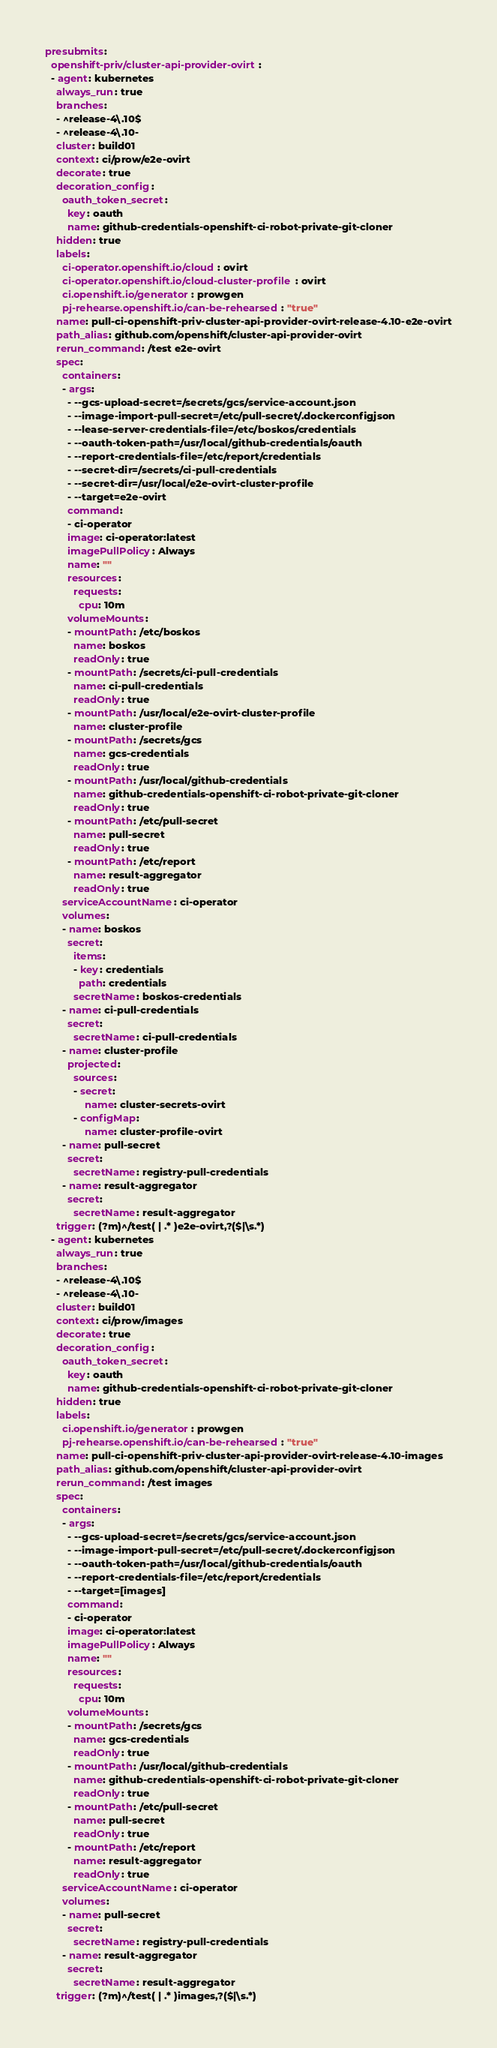<code> <loc_0><loc_0><loc_500><loc_500><_YAML_>presubmits:
  openshift-priv/cluster-api-provider-ovirt:
  - agent: kubernetes
    always_run: true
    branches:
    - ^release-4\.10$
    - ^release-4\.10-
    cluster: build01
    context: ci/prow/e2e-ovirt
    decorate: true
    decoration_config:
      oauth_token_secret:
        key: oauth
        name: github-credentials-openshift-ci-robot-private-git-cloner
    hidden: true
    labels:
      ci-operator.openshift.io/cloud: ovirt
      ci-operator.openshift.io/cloud-cluster-profile: ovirt
      ci.openshift.io/generator: prowgen
      pj-rehearse.openshift.io/can-be-rehearsed: "true"
    name: pull-ci-openshift-priv-cluster-api-provider-ovirt-release-4.10-e2e-ovirt
    path_alias: github.com/openshift/cluster-api-provider-ovirt
    rerun_command: /test e2e-ovirt
    spec:
      containers:
      - args:
        - --gcs-upload-secret=/secrets/gcs/service-account.json
        - --image-import-pull-secret=/etc/pull-secret/.dockerconfigjson
        - --lease-server-credentials-file=/etc/boskos/credentials
        - --oauth-token-path=/usr/local/github-credentials/oauth
        - --report-credentials-file=/etc/report/credentials
        - --secret-dir=/secrets/ci-pull-credentials
        - --secret-dir=/usr/local/e2e-ovirt-cluster-profile
        - --target=e2e-ovirt
        command:
        - ci-operator
        image: ci-operator:latest
        imagePullPolicy: Always
        name: ""
        resources:
          requests:
            cpu: 10m
        volumeMounts:
        - mountPath: /etc/boskos
          name: boskos
          readOnly: true
        - mountPath: /secrets/ci-pull-credentials
          name: ci-pull-credentials
          readOnly: true
        - mountPath: /usr/local/e2e-ovirt-cluster-profile
          name: cluster-profile
        - mountPath: /secrets/gcs
          name: gcs-credentials
          readOnly: true
        - mountPath: /usr/local/github-credentials
          name: github-credentials-openshift-ci-robot-private-git-cloner
          readOnly: true
        - mountPath: /etc/pull-secret
          name: pull-secret
          readOnly: true
        - mountPath: /etc/report
          name: result-aggregator
          readOnly: true
      serviceAccountName: ci-operator
      volumes:
      - name: boskos
        secret:
          items:
          - key: credentials
            path: credentials
          secretName: boskos-credentials
      - name: ci-pull-credentials
        secret:
          secretName: ci-pull-credentials
      - name: cluster-profile
        projected:
          sources:
          - secret:
              name: cluster-secrets-ovirt
          - configMap:
              name: cluster-profile-ovirt
      - name: pull-secret
        secret:
          secretName: registry-pull-credentials
      - name: result-aggregator
        secret:
          secretName: result-aggregator
    trigger: (?m)^/test( | .* )e2e-ovirt,?($|\s.*)
  - agent: kubernetes
    always_run: true
    branches:
    - ^release-4\.10$
    - ^release-4\.10-
    cluster: build01
    context: ci/prow/images
    decorate: true
    decoration_config:
      oauth_token_secret:
        key: oauth
        name: github-credentials-openshift-ci-robot-private-git-cloner
    hidden: true
    labels:
      ci.openshift.io/generator: prowgen
      pj-rehearse.openshift.io/can-be-rehearsed: "true"
    name: pull-ci-openshift-priv-cluster-api-provider-ovirt-release-4.10-images
    path_alias: github.com/openshift/cluster-api-provider-ovirt
    rerun_command: /test images
    spec:
      containers:
      - args:
        - --gcs-upload-secret=/secrets/gcs/service-account.json
        - --image-import-pull-secret=/etc/pull-secret/.dockerconfigjson
        - --oauth-token-path=/usr/local/github-credentials/oauth
        - --report-credentials-file=/etc/report/credentials
        - --target=[images]
        command:
        - ci-operator
        image: ci-operator:latest
        imagePullPolicy: Always
        name: ""
        resources:
          requests:
            cpu: 10m
        volumeMounts:
        - mountPath: /secrets/gcs
          name: gcs-credentials
          readOnly: true
        - mountPath: /usr/local/github-credentials
          name: github-credentials-openshift-ci-robot-private-git-cloner
          readOnly: true
        - mountPath: /etc/pull-secret
          name: pull-secret
          readOnly: true
        - mountPath: /etc/report
          name: result-aggregator
          readOnly: true
      serviceAccountName: ci-operator
      volumes:
      - name: pull-secret
        secret:
          secretName: registry-pull-credentials
      - name: result-aggregator
        secret:
          secretName: result-aggregator
    trigger: (?m)^/test( | .* )images,?($|\s.*)
</code> 